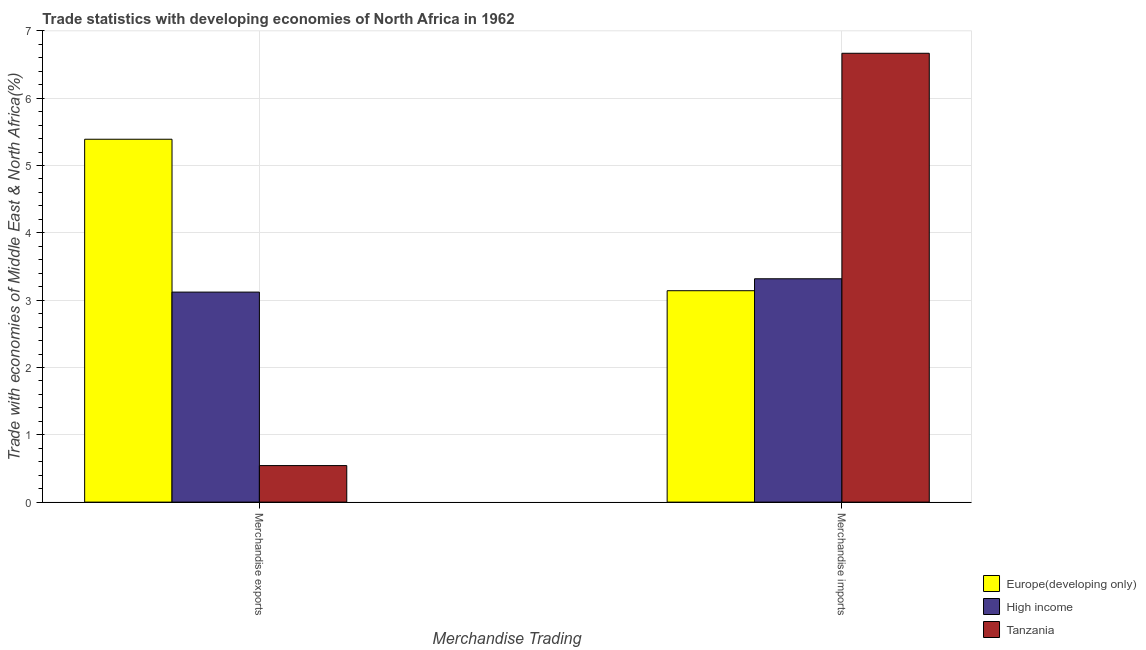How many groups of bars are there?
Offer a terse response. 2. Are the number of bars per tick equal to the number of legend labels?
Provide a succinct answer. Yes. What is the merchandise exports in High income?
Keep it short and to the point. 3.12. Across all countries, what is the maximum merchandise imports?
Give a very brief answer. 6.67. Across all countries, what is the minimum merchandise imports?
Your answer should be compact. 3.14. In which country was the merchandise exports maximum?
Keep it short and to the point. Europe(developing only). In which country was the merchandise exports minimum?
Provide a succinct answer. Tanzania. What is the total merchandise imports in the graph?
Offer a terse response. 13.12. What is the difference between the merchandise exports in Europe(developing only) and that in High income?
Keep it short and to the point. 2.27. What is the difference between the merchandise imports in Tanzania and the merchandise exports in High income?
Provide a short and direct response. 3.55. What is the average merchandise exports per country?
Give a very brief answer. 3.02. What is the difference between the merchandise imports and merchandise exports in Europe(developing only)?
Offer a very short reply. -2.25. In how many countries, is the merchandise imports greater than 0.6000000000000001 %?
Offer a terse response. 3. What is the ratio of the merchandise imports in Tanzania to that in High income?
Make the answer very short. 2.01. What does the 1st bar from the left in Merchandise imports represents?
Your response must be concise. Europe(developing only). What does the 1st bar from the right in Merchandise exports represents?
Give a very brief answer. Tanzania. How many bars are there?
Keep it short and to the point. 6. How many countries are there in the graph?
Your answer should be very brief. 3. Does the graph contain grids?
Keep it short and to the point. Yes. What is the title of the graph?
Provide a succinct answer. Trade statistics with developing economies of North Africa in 1962. What is the label or title of the X-axis?
Provide a succinct answer. Merchandise Trading. What is the label or title of the Y-axis?
Give a very brief answer. Trade with economies of Middle East & North Africa(%). What is the Trade with economies of Middle East & North Africa(%) of Europe(developing only) in Merchandise exports?
Offer a very short reply. 5.39. What is the Trade with economies of Middle East & North Africa(%) of High income in Merchandise exports?
Provide a succinct answer. 3.12. What is the Trade with economies of Middle East & North Africa(%) of Tanzania in Merchandise exports?
Ensure brevity in your answer.  0.54. What is the Trade with economies of Middle East & North Africa(%) of Europe(developing only) in Merchandise imports?
Your response must be concise. 3.14. What is the Trade with economies of Middle East & North Africa(%) in High income in Merchandise imports?
Keep it short and to the point. 3.32. What is the Trade with economies of Middle East & North Africa(%) of Tanzania in Merchandise imports?
Ensure brevity in your answer.  6.67. Across all Merchandise Trading, what is the maximum Trade with economies of Middle East & North Africa(%) in Europe(developing only)?
Your answer should be very brief. 5.39. Across all Merchandise Trading, what is the maximum Trade with economies of Middle East & North Africa(%) in High income?
Ensure brevity in your answer.  3.32. Across all Merchandise Trading, what is the maximum Trade with economies of Middle East & North Africa(%) of Tanzania?
Make the answer very short. 6.67. Across all Merchandise Trading, what is the minimum Trade with economies of Middle East & North Africa(%) in Europe(developing only)?
Keep it short and to the point. 3.14. Across all Merchandise Trading, what is the minimum Trade with economies of Middle East & North Africa(%) in High income?
Provide a succinct answer. 3.12. Across all Merchandise Trading, what is the minimum Trade with economies of Middle East & North Africa(%) of Tanzania?
Provide a succinct answer. 0.54. What is the total Trade with economies of Middle East & North Africa(%) in Europe(developing only) in the graph?
Provide a short and direct response. 8.53. What is the total Trade with economies of Middle East & North Africa(%) of High income in the graph?
Provide a succinct answer. 6.44. What is the total Trade with economies of Middle East & North Africa(%) in Tanzania in the graph?
Your answer should be compact. 7.21. What is the difference between the Trade with economies of Middle East & North Africa(%) in Europe(developing only) in Merchandise exports and that in Merchandise imports?
Make the answer very short. 2.25. What is the difference between the Trade with economies of Middle East & North Africa(%) of High income in Merchandise exports and that in Merchandise imports?
Keep it short and to the point. -0.2. What is the difference between the Trade with economies of Middle East & North Africa(%) of Tanzania in Merchandise exports and that in Merchandise imports?
Offer a very short reply. -6.12. What is the difference between the Trade with economies of Middle East & North Africa(%) in Europe(developing only) in Merchandise exports and the Trade with economies of Middle East & North Africa(%) in High income in Merchandise imports?
Give a very brief answer. 2.07. What is the difference between the Trade with economies of Middle East & North Africa(%) of Europe(developing only) in Merchandise exports and the Trade with economies of Middle East & North Africa(%) of Tanzania in Merchandise imports?
Provide a short and direct response. -1.28. What is the difference between the Trade with economies of Middle East & North Africa(%) in High income in Merchandise exports and the Trade with economies of Middle East & North Africa(%) in Tanzania in Merchandise imports?
Provide a short and direct response. -3.55. What is the average Trade with economies of Middle East & North Africa(%) in Europe(developing only) per Merchandise Trading?
Provide a succinct answer. 4.26. What is the average Trade with economies of Middle East & North Africa(%) in High income per Merchandise Trading?
Provide a short and direct response. 3.22. What is the average Trade with economies of Middle East & North Africa(%) of Tanzania per Merchandise Trading?
Your answer should be compact. 3.6. What is the difference between the Trade with economies of Middle East & North Africa(%) of Europe(developing only) and Trade with economies of Middle East & North Africa(%) of High income in Merchandise exports?
Your answer should be compact. 2.27. What is the difference between the Trade with economies of Middle East & North Africa(%) of Europe(developing only) and Trade with economies of Middle East & North Africa(%) of Tanzania in Merchandise exports?
Make the answer very short. 4.85. What is the difference between the Trade with economies of Middle East & North Africa(%) of High income and Trade with economies of Middle East & North Africa(%) of Tanzania in Merchandise exports?
Ensure brevity in your answer.  2.58. What is the difference between the Trade with economies of Middle East & North Africa(%) of Europe(developing only) and Trade with economies of Middle East & North Africa(%) of High income in Merchandise imports?
Make the answer very short. -0.18. What is the difference between the Trade with economies of Middle East & North Africa(%) in Europe(developing only) and Trade with economies of Middle East & North Africa(%) in Tanzania in Merchandise imports?
Ensure brevity in your answer.  -3.53. What is the difference between the Trade with economies of Middle East & North Africa(%) in High income and Trade with economies of Middle East & North Africa(%) in Tanzania in Merchandise imports?
Your answer should be very brief. -3.35. What is the ratio of the Trade with economies of Middle East & North Africa(%) of Europe(developing only) in Merchandise exports to that in Merchandise imports?
Offer a terse response. 1.72. What is the ratio of the Trade with economies of Middle East & North Africa(%) in High income in Merchandise exports to that in Merchandise imports?
Offer a very short reply. 0.94. What is the ratio of the Trade with economies of Middle East & North Africa(%) of Tanzania in Merchandise exports to that in Merchandise imports?
Provide a short and direct response. 0.08. What is the difference between the highest and the second highest Trade with economies of Middle East & North Africa(%) in Europe(developing only)?
Give a very brief answer. 2.25. What is the difference between the highest and the second highest Trade with economies of Middle East & North Africa(%) in High income?
Make the answer very short. 0.2. What is the difference between the highest and the second highest Trade with economies of Middle East & North Africa(%) of Tanzania?
Your response must be concise. 6.12. What is the difference between the highest and the lowest Trade with economies of Middle East & North Africa(%) of Europe(developing only)?
Your answer should be very brief. 2.25. What is the difference between the highest and the lowest Trade with economies of Middle East & North Africa(%) in High income?
Provide a succinct answer. 0.2. What is the difference between the highest and the lowest Trade with economies of Middle East & North Africa(%) in Tanzania?
Your response must be concise. 6.12. 